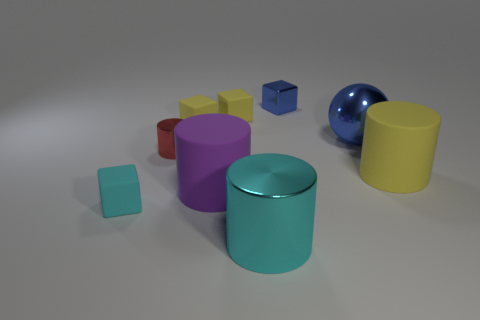There is a cyan metallic object; does it have the same shape as the cyan object that is behind the cyan cylinder?
Your response must be concise. No. There is a big cyan metal cylinder in front of the big cylinder that is behind the big purple matte cylinder; are there any shiny spheres behind it?
Provide a short and direct response. Yes. What is the size of the metallic object that is left of the big cyan metallic object?
Offer a very short reply. Small. What material is the cyan thing that is the same size as the blue block?
Keep it short and to the point. Rubber. Does the tiny red shiny object have the same shape as the cyan rubber object?
Give a very brief answer. No. What number of objects are either cyan cubes or small things in front of the large yellow rubber thing?
Give a very brief answer. 1. There is a block that is the same color as the large metallic cylinder; what is its material?
Give a very brief answer. Rubber. Is the size of the rubber cube that is in front of the blue ball the same as the tiny cylinder?
Keep it short and to the point. Yes. There is a large matte cylinder that is to the left of the yellow rubber thing to the right of the large blue thing; what number of small rubber objects are behind it?
Provide a succinct answer. 2. How many yellow objects are either big matte objects or small matte things?
Your answer should be compact. 3. 